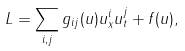Convert formula to latex. <formula><loc_0><loc_0><loc_500><loc_500>L = \sum _ { i , j } g _ { i j } ( u ) u _ { x } ^ { i } u _ { t } ^ { j } + f ( u ) ,</formula> 